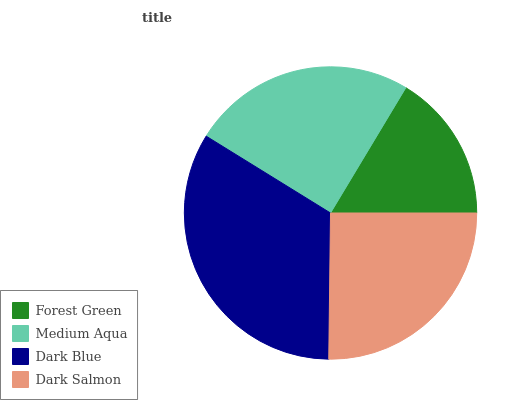Is Forest Green the minimum?
Answer yes or no. Yes. Is Dark Blue the maximum?
Answer yes or no. Yes. Is Medium Aqua the minimum?
Answer yes or no. No. Is Medium Aqua the maximum?
Answer yes or no. No. Is Medium Aqua greater than Forest Green?
Answer yes or no. Yes. Is Forest Green less than Medium Aqua?
Answer yes or no. Yes. Is Forest Green greater than Medium Aqua?
Answer yes or no. No. Is Medium Aqua less than Forest Green?
Answer yes or no. No. Is Dark Salmon the high median?
Answer yes or no. Yes. Is Medium Aqua the low median?
Answer yes or no. Yes. Is Dark Blue the high median?
Answer yes or no. No. Is Forest Green the low median?
Answer yes or no. No. 